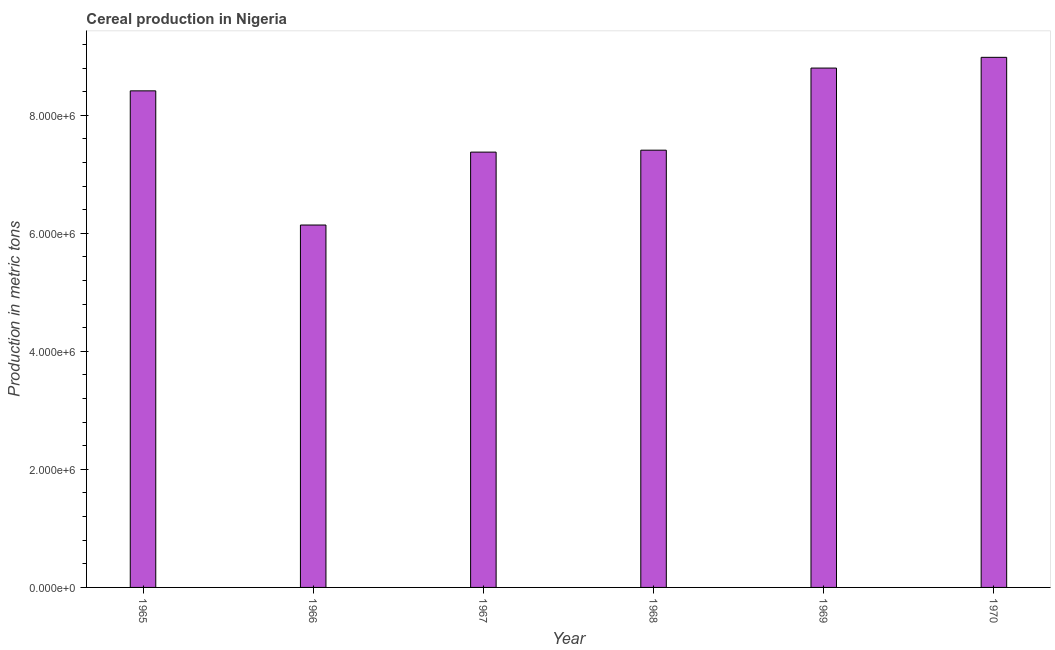Does the graph contain any zero values?
Your answer should be very brief. No. What is the title of the graph?
Provide a succinct answer. Cereal production in Nigeria. What is the label or title of the X-axis?
Ensure brevity in your answer.  Year. What is the label or title of the Y-axis?
Provide a succinct answer. Production in metric tons. What is the cereal production in 1969?
Offer a terse response. 8.80e+06. Across all years, what is the maximum cereal production?
Provide a short and direct response. 8.98e+06. Across all years, what is the minimum cereal production?
Offer a terse response. 6.14e+06. In which year was the cereal production maximum?
Your answer should be very brief. 1970. In which year was the cereal production minimum?
Provide a succinct answer. 1966. What is the sum of the cereal production?
Give a very brief answer. 4.71e+07. What is the difference between the cereal production in 1965 and 1969?
Give a very brief answer. -3.86e+05. What is the average cereal production per year?
Your response must be concise. 7.85e+06. What is the median cereal production?
Provide a short and direct response. 7.91e+06. What is the ratio of the cereal production in 1968 to that in 1969?
Give a very brief answer. 0.84. Is the cereal production in 1967 less than that in 1970?
Offer a very short reply. Yes. Is the difference between the cereal production in 1965 and 1968 greater than the difference between any two years?
Offer a very short reply. No. What is the difference between the highest and the second highest cereal production?
Your response must be concise. 1.82e+05. Is the sum of the cereal production in 1965 and 1967 greater than the maximum cereal production across all years?
Your answer should be compact. Yes. What is the difference between the highest and the lowest cereal production?
Ensure brevity in your answer.  2.84e+06. In how many years, is the cereal production greater than the average cereal production taken over all years?
Ensure brevity in your answer.  3. How many bars are there?
Give a very brief answer. 6. Are all the bars in the graph horizontal?
Ensure brevity in your answer.  No. How many years are there in the graph?
Provide a succinct answer. 6. What is the difference between two consecutive major ticks on the Y-axis?
Provide a short and direct response. 2.00e+06. Are the values on the major ticks of Y-axis written in scientific E-notation?
Ensure brevity in your answer.  Yes. What is the Production in metric tons of 1965?
Ensure brevity in your answer.  8.41e+06. What is the Production in metric tons of 1966?
Your response must be concise. 6.14e+06. What is the Production in metric tons in 1967?
Ensure brevity in your answer.  7.38e+06. What is the Production in metric tons in 1968?
Provide a succinct answer. 7.41e+06. What is the Production in metric tons of 1969?
Offer a terse response. 8.80e+06. What is the Production in metric tons in 1970?
Provide a short and direct response. 8.98e+06. What is the difference between the Production in metric tons in 1965 and 1966?
Provide a short and direct response. 2.27e+06. What is the difference between the Production in metric tons in 1965 and 1967?
Your answer should be very brief. 1.04e+06. What is the difference between the Production in metric tons in 1965 and 1968?
Make the answer very short. 1.00e+06. What is the difference between the Production in metric tons in 1965 and 1969?
Provide a short and direct response. -3.86e+05. What is the difference between the Production in metric tons in 1965 and 1970?
Make the answer very short. -5.68e+05. What is the difference between the Production in metric tons in 1966 and 1967?
Provide a succinct answer. -1.24e+06. What is the difference between the Production in metric tons in 1966 and 1968?
Keep it short and to the point. -1.27e+06. What is the difference between the Production in metric tons in 1966 and 1969?
Provide a short and direct response. -2.66e+06. What is the difference between the Production in metric tons in 1966 and 1970?
Your answer should be compact. -2.84e+06. What is the difference between the Production in metric tons in 1967 and 1968?
Provide a short and direct response. -3.30e+04. What is the difference between the Production in metric tons in 1967 and 1969?
Make the answer very short. -1.42e+06. What is the difference between the Production in metric tons in 1967 and 1970?
Your answer should be compact. -1.61e+06. What is the difference between the Production in metric tons in 1968 and 1969?
Your answer should be compact. -1.39e+06. What is the difference between the Production in metric tons in 1968 and 1970?
Keep it short and to the point. -1.57e+06. What is the difference between the Production in metric tons in 1969 and 1970?
Offer a very short reply. -1.82e+05. What is the ratio of the Production in metric tons in 1965 to that in 1966?
Provide a short and direct response. 1.37. What is the ratio of the Production in metric tons in 1965 to that in 1967?
Offer a very short reply. 1.14. What is the ratio of the Production in metric tons in 1965 to that in 1968?
Your answer should be very brief. 1.14. What is the ratio of the Production in metric tons in 1965 to that in 1969?
Ensure brevity in your answer.  0.96. What is the ratio of the Production in metric tons in 1965 to that in 1970?
Provide a short and direct response. 0.94. What is the ratio of the Production in metric tons in 1966 to that in 1967?
Offer a terse response. 0.83. What is the ratio of the Production in metric tons in 1966 to that in 1968?
Provide a succinct answer. 0.83. What is the ratio of the Production in metric tons in 1966 to that in 1969?
Provide a succinct answer. 0.7. What is the ratio of the Production in metric tons in 1966 to that in 1970?
Your answer should be compact. 0.68. What is the ratio of the Production in metric tons in 1967 to that in 1969?
Offer a terse response. 0.84. What is the ratio of the Production in metric tons in 1967 to that in 1970?
Keep it short and to the point. 0.82. What is the ratio of the Production in metric tons in 1968 to that in 1969?
Ensure brevity in your answer.  0.84. What is the ratio of the Production in metric tons in 1968 to that in 1970?
Keep it short and to the point. 0.82. 